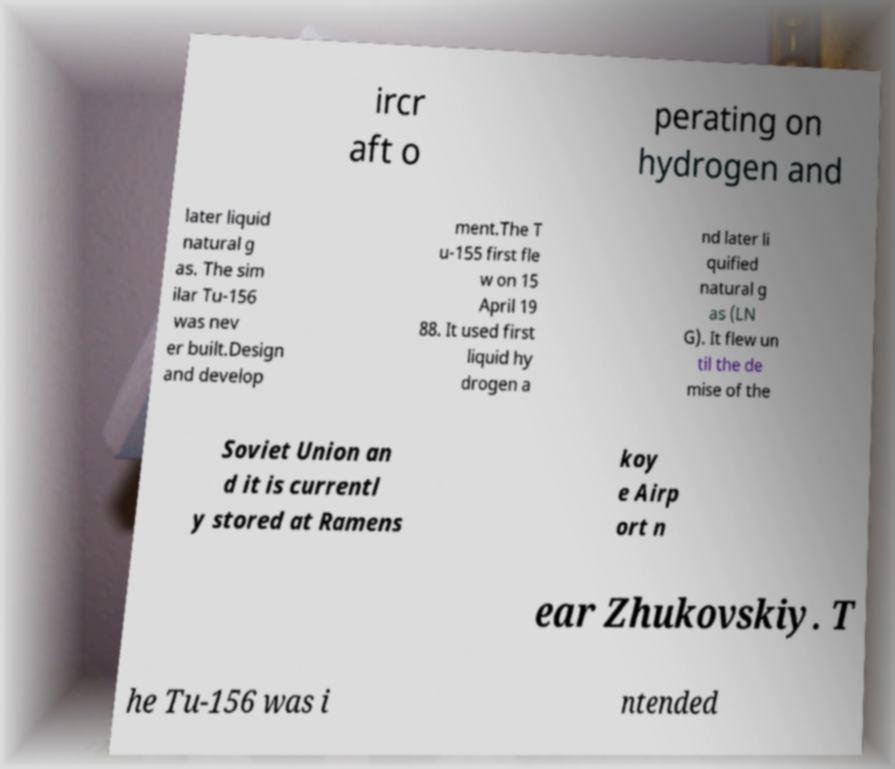Could you extract and type out the text from this image? ircr aft o perating on hydrogen and later liquid natural g as. The sim ilar Tu-156 was nev er built.Design and develop ment.The T u-155 first fle w on 15 April 19 88. It used first liquid hy drogen a nd later li quified natural g as (LN G). It flew un til the de mise of the Soviet Union an d it is currentl y stored at Ramens koy e Airp ort n ear Zhukovskiy. T he Tu-156 was i ntended 